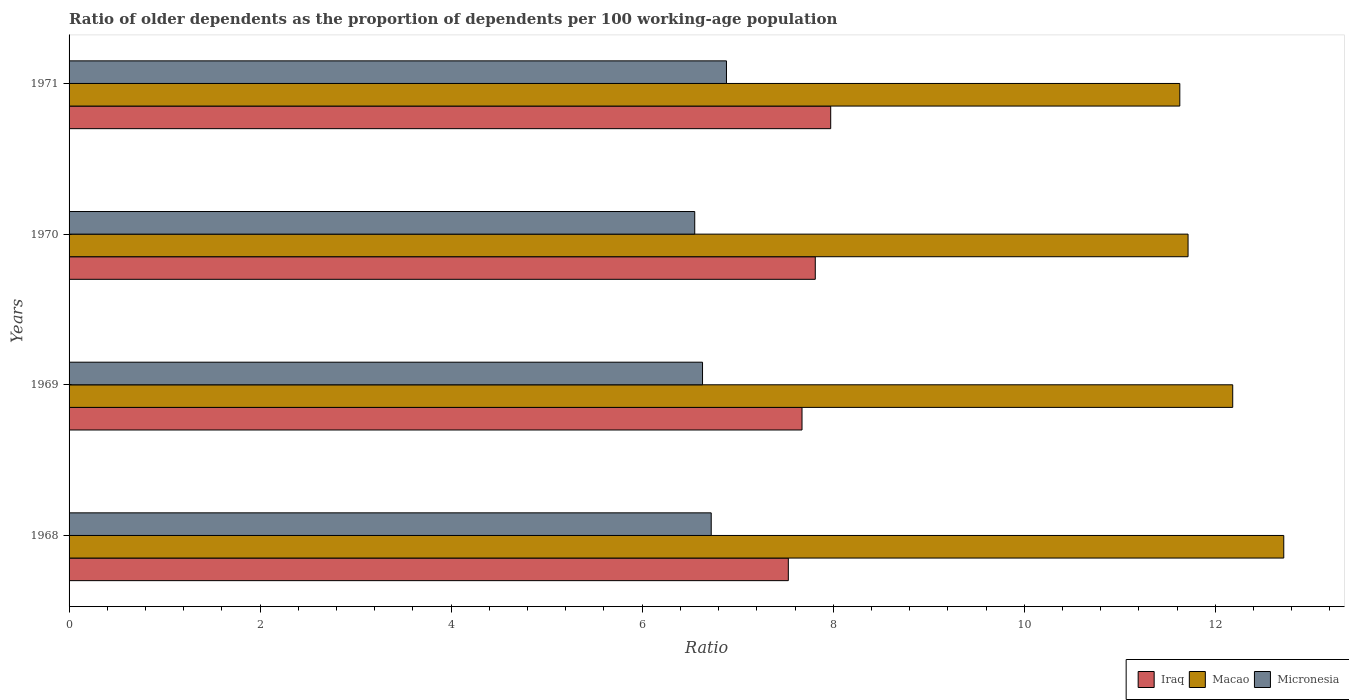How many different coloured bars are there?
Keep it short and to the point. 3. How many groups of bars are there?
Keep it short and to the point. 4. Are the number of bars per tick equal to the number of legend labels?
Your response must be concise. Yes. How many bars are there on the 1st tick from the top?
Your response must be concise. 3. What is the label of the 3rd group of bars from the top?
Provide a short and direct response. 1969. What is the age dependency ratio(old) in Micronesia in 1968?
Give a very brief answer. 6.72. Across all years, what is the maximum age dependency ratio(old) in Iraq?
Keep it short and to the point. 7.97. Across all years, what is the minimum age dependency ratio(old) in Iraq?
Offer a terse response. 7.53. In which year was the age dependency ratio(old) in Iraq minimum?
Make the answer very short. 1968. What is the total age dependency ratio(old) in Micronesia in the graph?
Offer a terse response. 26.79. What is the difference between the age dependency ratio(old) in Micronesia in 1969 and that in 1970?
Give a very brief answer. 0.08. What is the difference between the age dependency ratio(old) in Micronesia in 1970 and the age dependency ratio(old) in Macao in 1968?
Provide a succinct answer. -6.17. What is the average age dependency ratio(old) in Macao per year?
Offer a terse response. 12.06. In the year 1969, what is the difference between the age dependency ratio(old) in Macao and age dependency ratio(old) in Micronesia?
Offer a very short reply. 5.55. What is the ratio of the age dependency ratio(old) in Micronesia in 1968 to that in 1971?
Provide a succinct answer. 0.98. Is the age dependency ratio(old) in Micronesia in 1969 less than that in 1970?
Keep it short and to the point. No. Is the difference between the age dependency ratio(old) in Macao in 1969 and 1971 greater than the difference between the age dependency ratio(old) in Micronesia in 1969 and 1971?
Your response must be concise. Yes. What is the difference between the highest and the second highest age dependency ratio(old) in Micronesia?
Provide a succinct answer. 0.16. What is the difference between the highest and the lowest age dependency ratio(old) in Micronesia?
Your answer should be very brief. 0.33. Is the sum of the age dependency ratio(old) in Micronesia in 1969 and 1970 greater than the maximum age dependency ratio(old) in Macao across all years?
Ensure brevity in your answer.  Yes. What does the 1st bar from the top in 1968 represents?
Your response must be concise. Micronesia. What does the 3rd bar from the bottom in 1969 represents?
Keep it short and to the point. Micronesia. How many years are there in the graph?
Offer a terse response. 4. Are the values on the major ticks of X-axis written in scientific E-notation?
Provide a succinct answer. No. Where does the legend appear in the graph?
Your answer should be compact. Bottom right. How many legend labels are there?
Offer a very short reply. 3. How are the legend labels stacked?
Give a very brief answer. Horizontal. What is the title of the graph?
Your response must be concise. Ratio of older dependents as the proportion of dependents per 100 working-age population. What is the label or title of the X-axis?
Provide a short and direct response. Ratio. What is the label or title of the Y-axis?
Offer a very short reply. Years. What is the Ratio in Iraq in 1968?
Provide a succinct answer. 7.53. What is the Ratio in Macao in 1968?
Provide a succinct answer. 12.72. What is the Ratio in Micronesia in 1968?
Offer a terse response. 6.72. What is the Ratio in Iraq in 1969?
Offer a terse response. 7.67. What is the Ratio in Macao in 1969?
Your response must be concise. 12.18. What is the Ratio of Micronesia in 1969?
Ensure brevity in your answer.  6.63. What is the Ratio in Iraq in 1970?
Offer a terse response. 7.81. What is the Ratio in Macao in 1970?
Ensure brevity in your answer.  11.71. What is the Ratio in Micronesia in 1970?
Your answer should be very brief. 6.55. What is the Ratio in Iraq in 1971?
Provide a short and direct response. 7.97. What is the Ratio of Macao in 1971?
Your response must be concise. 11.63. What is the Ratio of Micronesia in 1971?
Make the answer very short. 6.88. Across all years, what is the maximum Ratio of Iraq?
Make the answer very short. 7.97. Across all years, what is the maximum Ratio of Macao?
Your response must be concise. 12.72. Across all years, what is the maximum Ratio of Micronesia?
Provide a short and direct response. 6.88. Across all years, what is the minimum Ratio in Iraq?
Make the answer very short. 7.53. Across all years, what is the minimum Ratio of Macao?
Ensure brevity in your answer.  11.63. Across all years, what is the minimum Ratio of Micronesia?
Your response must be concise. 6.55. What is the total Ratio of Iraq in the graph?
Provide a short and direct response. 30.99. What is the total Ratio of Macao in the graph?
Offer a very short reply. 48.24. What is the total Ratio in Micronesia in the graph?
Your answer should be very brief. 26.79. What is the difference between the Ratio of Iraq in 1968 and that in 1969?
Your answer should be very brief. -0.14. What is the difference between the Ratio in Macao in 1968 and that in 1969?
Provide a succinct answer. 0.53. What is the difference between the Ratio of Micronesia in 1968 and that in 1969?
Your answer should be compact. 0.09. What is the difference between the Ratio of Iraq in 1968 and that in 1970?
Offer a terse response. -0.28. What is the difference between the Ratio in Micronesia in 1968 and that in 1970?
Your answer should be very brief. 0.17. What is the difference between the Ratio of Iraq in 1968 and that in 1971?
Keep it short and to the point. -0.44. What is the difference between the Ratio of Macao in 1968 and that in 1971?
Offer a very short reply. 1.09. What is the difference between the Ratio of Micronesia in 1968 and that in 1971?
Your response must be concise. -0.16. What is the difference between the Ratio in Iraq in 1969 and that in 1970?
Give a very brief answer. -0.14. What is the difference between the Ratio in Macao in 1969 and that in 1970?
Give a very brief answer. 0.47. What is the difference between the Ratio in Micronesia in 1969 and that in 1970?
Offer a terse response. 0.08. What is the difference between the Ratio of Iraq in 1969 and that in 1971?
Your response must be concise. -0.3. What is the difference between the Ratio in Macao in 1969 and that in 1971?
Make the answer very short. 0.55. What is the difference between the Ratio in Micronesia in 1969 and that in 1971?
Provide a short and direct response. -0.25. What is the difference between the Ratio in Iraq in 1970 and that in 1971?
Ensure brevity in your answer.  -0.16. What is the difference between the Ratio in Macao in 1970 and that in 1971?
Provide a short and direct response. 0.09. What is the difference between the Ratio in Micronesia in 1970 and that in 1971?
Give a very brief answer. -0.33. What is the difference between the Ratio in Iraq in 1968 and the Ratio in Macao in 1969?
Your answer should be very brief. -4.65. What is the difference between the Ratio in Iraq in 1968 and the Ratio in Micronesia in 1969?
Provide a short and direct response. 0.9. What is the difference between the Ratio of Macao in 1968 and the Ratio of Micronesia in 1969?
Your answer should be compact. 6.08. What is the difference between the Ratio of Iraq in 1968 and the Ratio of Macao in 1970?
Provide a succinct answer. -4.18. What is the difference between the Ratio of Iraq in 1968 and the Ratio of Micronesia in 1970?
Provide a succinct answer. 0.98. What is the difference between the Ratio of Macao in 1968 and the Ratio of Micronesia in 1970?
Your answer should be very brief. 6.17. What is the difference between the Ratio in Iraq in 1968 and the Ratio in Macao in 1971?
Provide a short and direct response. -4.1. What is the difference between the Ratio in Iraq in 1968 and the Ratio in Micronesia in 1971?
Your answer should be very brief. 0.65. What is the difference between the Ratio in Macao in 1968 and the Ratio in Micronesia in 1971?
Keep it short and to the point. 5.83. What is the difference between the Ratio of Iraq in 1969 and the Ratio of Macao in 1970?
Provide a succinct answer. -4.04. What is the difference between the Ratio in Iraq in 1969 and the Ratio in Micronesia in 1970?
Your answer should be compact. 1.12. What is the difference between the Ratio of Macao in 1969 and the Ratio of Micronesia in 1970?
Make the answer very short. 5.63. What is the difference between the Ratio in Iraq in 1969 and the Ratio in Macao in 1971?
Your response must be concise. -3.96. What is the difference between the Ratio in Iraq in 1969 and the Ratio in Micronesia in 1971?
Provide a succinct answer. 0.79. What is the difference between the Ratio of Macao in 1969 and the Ratio of Micronesia in 1971?
Provide a short and direct response. 5.3. What is the difference between the Ratio in Iraq in 1970 and the Ratio in Macao in 1971?
Your answer should be compact. -3.82. What is the difference between the Ratio of Iraq in 1970 and the Ratio of Micronesia in 1971?
Provide a succinct answer. 0.93. What is the difference between the Ratio in Macao in 1970 and the Ratio in Micronesia in 1971?
Offer a terse response. 4.83. What is the average Ratio in Iraq per year?
Offer a terse response. 7.75. What is the average Ratio of Macao per year?
Your answer should be compact. 12.06. What is the average Ratio of Micronesia per year?
Provide a short and direct response. 6.7. In the year 1968, what is the difference between the Ratio in Iraq and Ratio in Macao?
Your response must be concise. -5.19. In the year 1968, what is the difference between the Ratio in Iraq and Ratio in Micronesia?
Your answer should be very brief. 0.81. In the year 1968, what is the difference between the Ratio of Macao and Ratio of Micronesia?
Your answer should be compact. 5.99. In the year 1969, what is the difference between the Ratio of Iraq and Ratio of Macao?
Keep it short and to the point. -4.51. In the year 1969, what is the difference between the Ratio in Iraq and Ratio in Micronesia?
Your answer should be very brief. 1.04. In the year 1969, what is the difference between the Ratio in Macao and Ratio in Micronesia?
Keep it short and to the point. 5.55. In the year 1970, what is the difference between the Ratio in Iraq and Ratio in Macao?
Provide a succinct answer. -3.9. In the year 1970, what is the difference between the Ratio of Iraq and Ratio of Micronesia?
Your answer should be compact. 1.26. In the year 1970, what is the difference between the Ratio in Macao and Ratio in Micronesia?
Offer a very short reply. 5.16. In the year 1971, what is the difference between the Ratio of Iraq and Ratio of Macao?
Give a very brief answer. -3.65. In the year 1971, what is the difference between the Ratio of Iraq and Ratio of Micronesia?
Provide a short and direct response. 1.09. In the year 1971, what is the difference between the Ratio of Macao and Ratio of Micronesia?
Provide a short and direct response. 4.75. What is the ratio of the Ratio of Iraq in 1968 to that in 1969?
Your response must be concise. 0.98. What is the ratio of the Ratio of Macao in 1968 to that in 1969?
Offer a very short reply. 1.04. What is the ratio of the Ratio of Micronesia in 1968 to that in 1969?
Your answer should be compact. 1.01. What is the ratio of the Ratio of Iraq in 1968 to that in 1970?
Ensure brevity in your answer.  0.96. What is the ratio of the Ratio of Macao in 1968 to that in 1970?
Your response must be concise. 1.09. What is the ratio of the Ratio in Micronesia in 1968 to that in 1970?
Provide a succinct answer. 1.03. What is the ratio of the Ratio in Iraq in 1968 to that in 1971?
Provide a short and direct response. 0.94. What is the ratio of the Ratio in Macao in 1968 to that in 1971?
Keep it short and to the point. 1.09. What is the ratio of the Ratio of Micronesia in 1968 to that in 1971?
Keep it short and to the point. 0.98. What is the ratio of the Ratio of Iraq in 1969 to that in 1970?
Offer a very short reply. 0.98. What is the ratio of the Ratio of Macao in 1969 to that in 1970?
Offer a terse response. 1.04. What is the ratio of the Ratio in Micronesia in 1969 to that in 1970?
Offer a terse response. 1.01. What is the ratio of the Ratio of Iraq in 1969 to that in 1971?
Your response must be concise. 0.96. What is the ratio of the Ratio in Macao in 1969 to that in 1971?
Your answer should be very brief. 1.05. What is the ratio of the Ratio in Micronesia in 1969 to that in 1971?
Your answer should be very brief. 0.96. What is the ratio of the Ratio of Iraq in 1970 to that in 1971?
Ensure brevity in your answer.  0.98. What is the ratio of the Ratio of Macao in 1970 to that in 1971?
Make the answer very short. 1.01. What is the ratio of the Ratio in Micronesia in 1970 to that in 1971?
Make the answer very short. 0.95. What is the difference between the highest and the second highest Ratio of Iraq?
Give a very brief answer. 0.16. What is the difference between the highest and the second highest Ratio of Macao?
Provide a short and direct response. 0.53. What is the difference between the highest and the second highest Ratio of Micronesia?
Offer a very short reply. 0.16. What is the difference between the highest and the lowest Ratio of Iraq?
Your response must be concise. 0.44. What is the difference between the highest and the lowest Ratio of Macao?
Keep it short and to the point. 1.09. What is the difference between the highest and the lowest Ratio in Micronesia?
Ensure brevity in your answer.  0.33. 